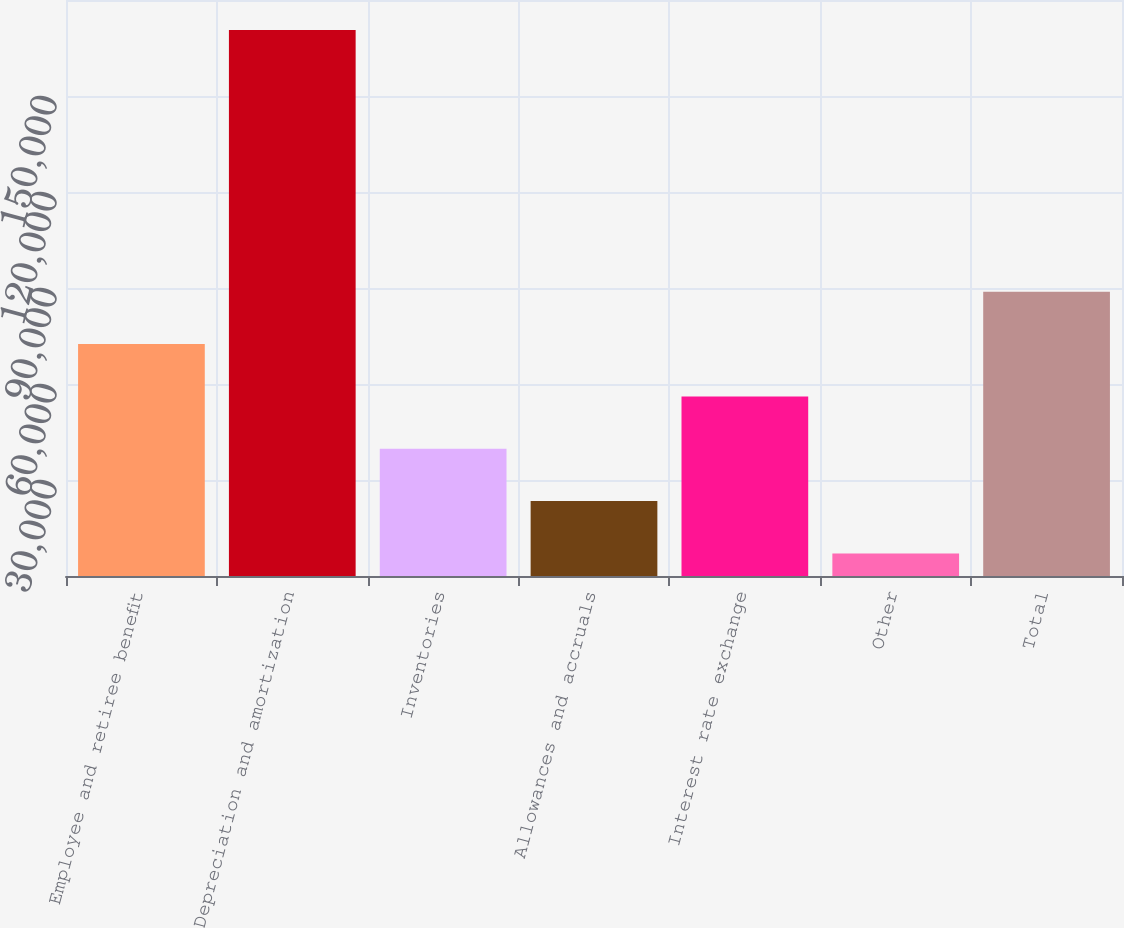<chart> <loc_0><loc_0><loc_500><loc_500><bar_chart><fcel>Employee and retiree benefit<fcel>Depreciation and amortization<fcel>Inventories<fcel>Allowances and accruals<fcel>Interest rate exchange<fcel>Other<fcel>Total<nl><fcel>72487.4<fcel>170630<fcel>39773.2<fcel>23416.1<fcel>56130.3<fcel>7059<fcel>88844.5<nl></chart> 